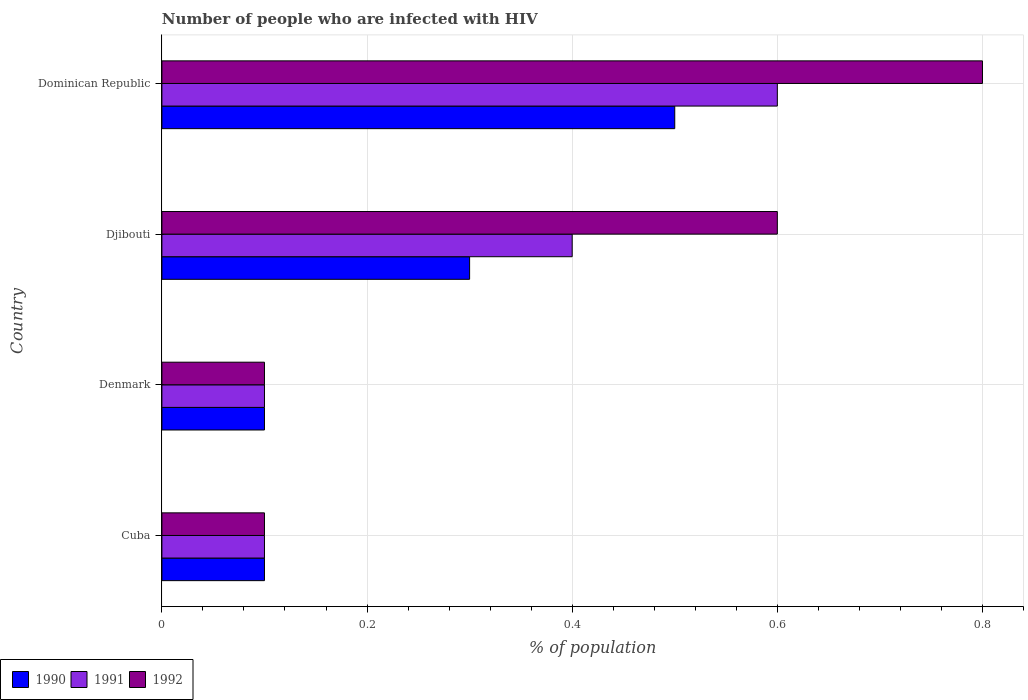Are the number of bars per tick equal to the number of legend labels?
Provide a short and direct response. Yes. How many bars are there on the 1st tick from the top?
Offer a very short reply. 3. How many bars are there on the 3rd tick from the bottom?
Provide a short and direct response. 3. What is the label of the 2nd group of bars from the top?
Ensure brevity in your answer.  Djibouti. Across all countries, what is the maximum percentage of HIV infected population in in 1992?
Provide a succinct answer. 0.8. Across all countries, what is the minimum percentage of HIV infected population in in 1990?
Give a very brief answer. 0.1. In which country was the percentage of HIV infected population in in 1990 maximum?
Your answer should be compact. Dominican Republic. In which country was the percentage of HIV infected population in in 1991 minimum?
Ensure brevity in your answer.  Cuba. What is the total percentage of HIV infected population in in 1992 in the graph?
Ensure brevity in your answer.  1.6. What is the difference between the percentage of HIV infected population in in 1992 in Cuba and that in Dominican Republic?
Provide a succinct answer. -0.7. What is the difference between the percentage of HIV infected population in in 1992 in Djibouti and the percentage of HIV infected population in in 1990 in Dominican Republic?
Your answer should be very brief. 0.1. What is the average percentage of HIV infected population in in 1991 per country?
Make the answer very short. 0.3. What is the difference between the percentage of HIV infected population in in 1991 and percentage of HIV infected population in in 1992 in Dominican Republic?
Give a very brief answer. -0.2. In how many countries, is the percentage of HIV infected population in in 1991 greater than 0.12 %?
Provide a succinct answer. 2. What is the ratio of the percentage of HIV infected population in in 1992 in Djibouti to that in Dominican Republic?
Ensure brevity in your answer.  0.75. Is the percentage of HIV infected population in in 1991 in Cuba less than that in Djibouti?
Your response must be concise. Yes. Is the difference between the percentage of HIV infected population in in 1991 in Cuba and Denmark greater than the difference between the percentage of HIV infected population in in 1992 in Cuba and Denmark?
Give a very brief answer. No. What is the difference between the highest and the second highest percentage of HIV infected population in in 1992?
Make the answer very short. 0.2. What is the difference between the highest and the lowest percentage of HIV infected population in in 1992?
Ensure brevity in your answer.  0.7. In how many countries, is the percentage of HIV infected population in in 1991 greater than the average percentage of HIV infected population in in 1991 taken over all countries?
Your response must be concise. 2. Is the sum of the percentage of HIV infected population in in 1992 in Cuba and Dominican Republic greater than the maximum percentage of HIV infected population in in 1990 across all countries?
Offer a terse response. Yes. What does the 1st bar from the top in Denmark represents?
Your answer should be compact. 1992. Is it the case that in every country, the sum of the percentage of HIV infected population in in 1991 and percentage of HIV infected population in in 1990 is greater than the percentage of HIV infected population in in 1992?
Ensure brevity in your answer.  Yes. Are all the bars in the graph horizontal?
Your answer should be very brief. Yes. What is the difference between two consecutive major ticks on the X-axis?
Provide a short and direct response. 0.2. Does the graph contain any zero values?
Give a very brief answer. No. How many legend labels are there?
Offer a terse response. 3. What is the title of the graph?
Ensure brevity in your answer.  Number of people who are infected with HIV. Does "1995" appear as one of the legend labels in the graph?
Your response must be concise. No. What is the label or title of the X-axis?
Provide a short and direct response. % of population. What is the label or title of the Y-axis?
Offer a terse response. Country. What is the % of population in 1991 in Denmark?
Provide a short and direct response. 0.1. What is the % of population in 1990 in Djibouti?
Keep it short and to the point. 0.3. What is the % of population in 1991 in Djibouti?
Your answer should be very brief. 0.4. Across all countries, what is the maximum % of population of 1990?
Ensure brevity in your answer.  0.5. Across all countries, what is the maximum % of population in 1992?
Give a very brief answer. 0.8. Across all countries, what is the minimum % of population in 1991?
Your answer should be compact. 0.1. Across all countries, what is the minimum % of population in 1992?
Your answer should be very brief. 0.1. What is the total % of population of 1992 in the graph?
Provide a succinct answer. 1.6. What is the difference between the % of population of 1990 in Cuba and that in Denmark?
Provide a short and direct response. 0. What is the difference between the % of population in 1992 in Cuba and that in Denmark?
Keep it short and to the point. 0. What is the difference between the % of population of 1990 in Cuba and that in Djibouti?
Your answer should be compact. -0.2. What is the difference between the % of population of 1992 in Cuba and that in Djibouti?
Provide a short and direct response. -0.5. What is the difference between the % of population in 1991 in Denmark and that in Djibouti?
Offer a terse response. -0.3. What is the difference between the % of population of 1992 in Denmark and that in Djibouti?
Your response must be concise. -0.5. What is the difference between the % of population of 1990 in Denmark and that in Dominican Republic?
Keep it short and to the point. -0.4. What is the difference between the % of population of 1991 in Denmark and that in Dominican Republic?
Offer a very short reply. -0.5. What is the difference between the % of population of 1992 in Djibouti and that in Dominican Republic?
Keep it short and to the point. -0.2. What is the difference between the % of population of 1990 in Cuba and the % of population of 1992 in Djibouti?
Keep it short and to the point. -0.5. What is the difference between the % of population of 1991 in Cuba and the % of population of 1992 in Djibouti?
Offer a very short reply. -0.5. What is the difference between the % of population in 1990 in Cuba and the % of population in 1991 in Dominican Republic?
Keep it short and to the point. -0.5. What is the difference between the % of population in 1990 in Denmark and the % of population in 1992 in Djibouti?
Give a very brief answer. -0.5. What is the difference between the % of population in 1991 in Denmark and the % of population in 1992 in Djibouti?
Give a very brief answer. -0.5. What is the difference between the % of population in 1990 in Denmark and the % of population in 1991 in Dominican Republic?
Give a very brief answer. -0.5. What is the difference between the % of population in 1990 in Djibouti and the % of population in 1992 in Dominican Republic?
Give a very brief answer. -0.5. What is the difference between the % of population in 1991 in Djibouti and the % of population in 1992 in Dominican Republic?
Give a very brief answer. -0.4. What is the average % of population of 1991 per country?
Your answer should be compact. 0.3. What is the difference between the % of population in 1990 and % of population in 1992 in Cuba?
Your answer should be compact. 0. What is the difference between the % of population in 1990 and % of population in 1992 in Denmark?
Offer a very short reply. 0. What is the difference between the % of population of 1990 and % of population of 1991 in Djibouti?
Your answer should be compact. -0.1. What is the difference between the % of population in 1990 and % of population in 1992 in Djibouti?
Offer a very short reply. -0.3. What is the difference between the % of population of 1991 and % of population of 1992 in Djibouti?
Provide a short and direct response. -0.2. What is the difference between the % of population of 1990 and % of population of 1991 in Dominican Republic?
Provide a succinct answer. -0.1. What is the difference between the % of population in 1991 and % of population in 1992 in Dominican Republic?
Offer a very short reply. -0.2. What is the ratio of the % of population of 1992 in Cuba to that in Denmark?
Offer a terse response. 1. What is the ratio of the % of population in 1991 in Cuba to that in Djibouti?
Your answer should be very brief. 0.25. What is the ratio of the % of population in 1990 in Denmark to that in Djibouti?
Provide a succinct answer. 0.33. What is the ratio of the % of population in 1991 in Denmark to that in Djibouti?
Give a very brief answer. 0.25. What is the ratio of the % of population of 1992 in Denmark to that in Djibouti?
Your response must be concise. 0.17. What is the ratio of the % of population in 1991 in Denmark to that in Dominican Republic?
Offer a very short reply. 0.17. What is the ratio of the % of population in 1992 in Denmark to that in Dominican Republic?
Provide a succinct answer. 0.12. What is the ratio of the % of population in 1990 in Djibouti to that in Dominican Republic?
Offer a terse response. 0.6. What is the ratio of the % of population of 1991 in Djibouti to that in Dominican Republic?
Give a very brief answer. 0.67. What is the difference between the highest and the second highest % of population in 1991?
Provide a short and direct response. 0.2. What is the difference between the highest and the second highest % of population in 1992?
Offer a very short reply. 0.2. What is the difference between the highest and the lowest % of population in 1990?
Give a very brief answer. 0.4. What is the difference between the highest and the lowest % of population in 1991?
Give a very brief answer. 0.5. 